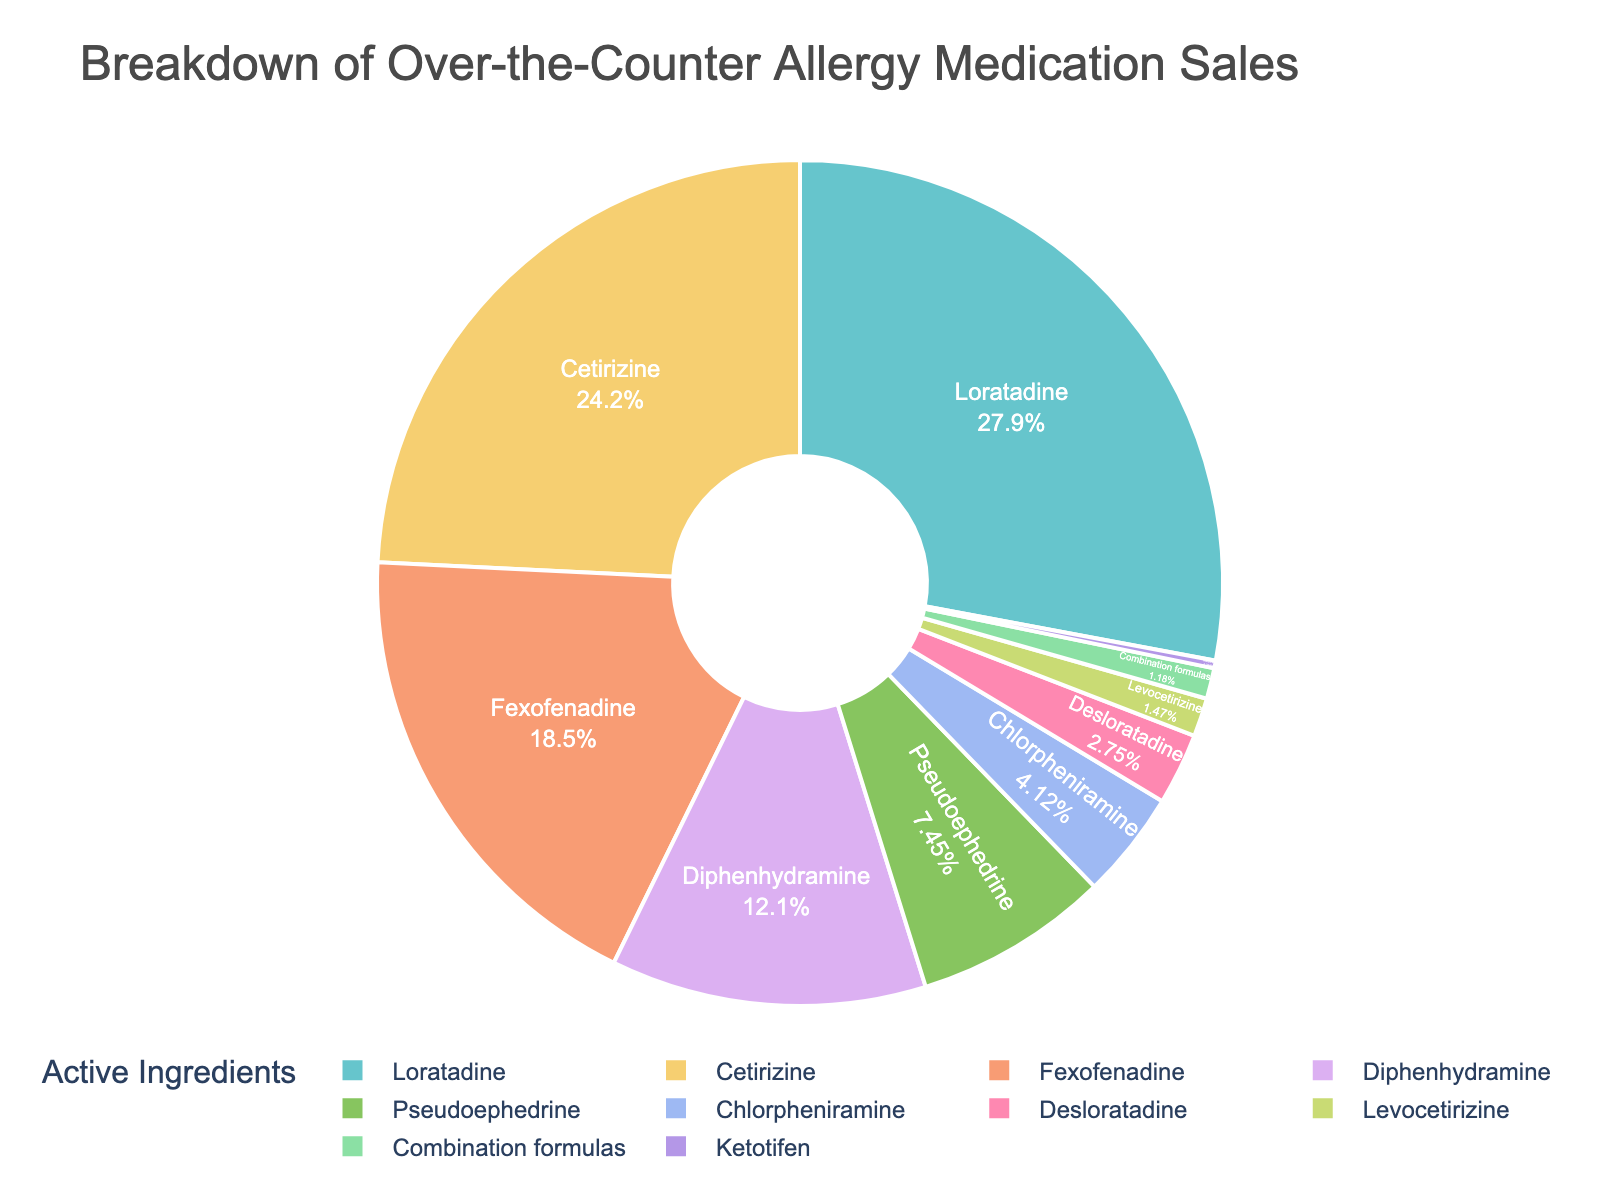What percentage of sales is attributed to Loratadine? Look at the Loratadine segment in the pie chart and read the percentage label.
Answer: 28.5% What is the combined percentage of sales for Loratadine and Cetirizine? Add the percentages of Loratadine (28.5%) and Cetirizine (24.7%). 28.5 + 24.7 = 53.2
Answer: 53.2% Which active ingredient has a lower percentage of sales, Pseudoephedrine or Levocetirizine? Compare the percentages of Pseudoephedrine (7.6%) and Levocetirizine (1.5%). 7.6 is greater than 1.5, so Levocetirizine is lower.
Answer: Levocetirizine Which ingredient category appears the smallest visually in the chart? Identify the smallest segment in the pie chart by visual inspection, which corresponds to the smallest percentage.
Answer: Ketotifen What is the total percentage of sales for the three ingredients with the lowest percentages? Add the percentages of Ketotifen (0.3%), Levocetirizine (1.5%), and Combination formulas (1.2%). 0.3 + 1.5 + 1.2 = 3.0
Answer: 3.0% How much greater is the sales percentage for Loratadine compared to Pseudoephedrine? Subtract the percentage of Pseudoephedrine (7.6) from Loratadine (28.5). 28.5 - 7.6 = 20.9
Answer: 20.9% Which active ingredient has the highest percentage of sales? Check the segment of the pie chart with the largest percentage label.
Answer: Loratadine What is the average percentage of sales for Cetirizine, Fexofenadine, and Diphenhydramine? Add the percentages of Cetirizine (24.7), Fexofenadine (18.9), and Diphenhydramine (12.3) and divide by 3. (24.7 + 18.9 + 12.3) / 3 = 18.63
Answer: 18.63% What percentage of sales is made up by the three most sold ingredients? Sum the percentages of Loratadine (28.5), Cetirizine (24.7), and Fexofenadine (18.9). 28.5 + 24.7 + 18.9 = 72.1
Answer: 72.1% Is the percentage for Cetirizine higher or lower than for Fexofenadine? Compare the percentages of Cetirizine (24.7) and Fexofenadine (18.9). 24.7 is greater than 18.9.
Answer: Higher 